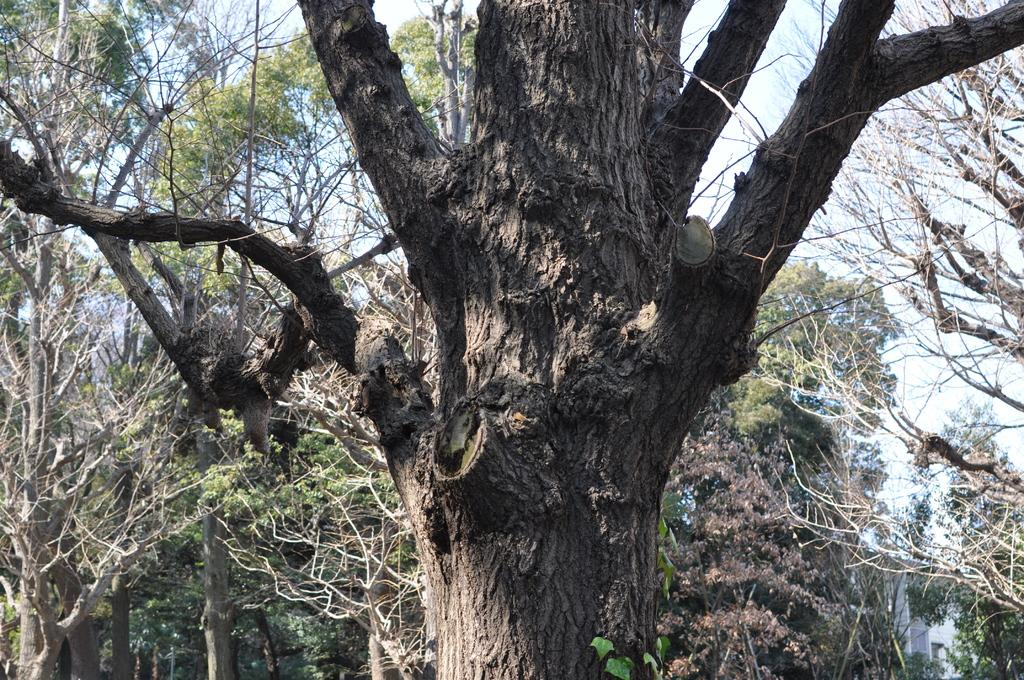What type of vegetation can be seen in the image? There are trees in the image. What type of structure is present in the image? There is a house in the image. What is visible in the background of the image? The sky is visible in the image. Can you determine the time of day the image was taken? The image was likely taken during the day, as there is no indication of darkness or artificial lighting. What type of engine can be seen in the image? There is no engine present in the image. 